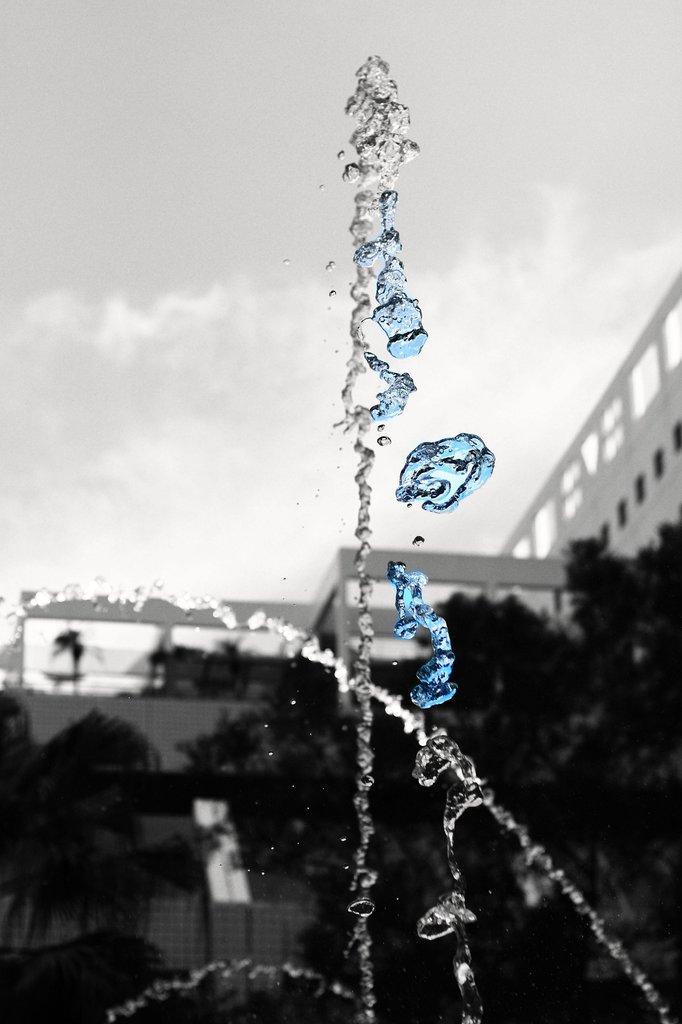What is one of the main elements in the image? There is water in the image. What type of natural elements can be seen in the image? There are trees in the image. What type of man-made structures are present in the image? There are buildings in the image. What else can be seen in the image besides water, trees, and buildings? There are objects in the image. What can be seen in the background of the image? The sky is visible in the background of the image. What type of treatment is being administered to the trees in the image? There is no treatment being administered to the trees in the image; they are simply standing in the background. 